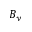<formula> <loc_0><loc_0><loc_500><loc_500>B _ { y }</formula> 